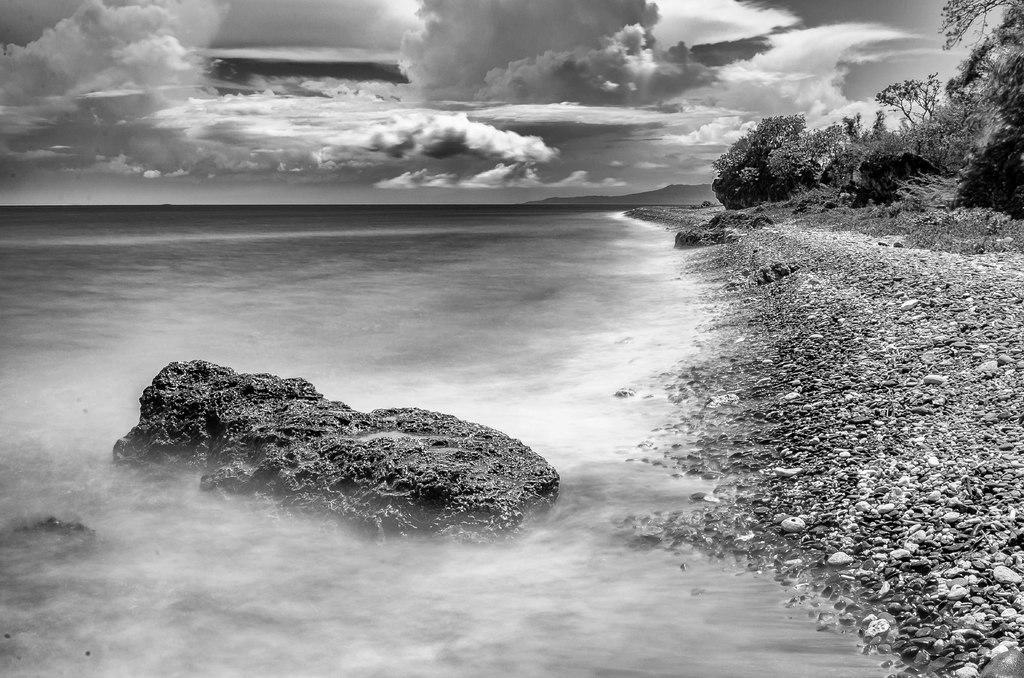In one or two sentences, can you explain what this image depicts? In this picture we can see water, few stones, trees and clouds, and it is a black and white photography. 